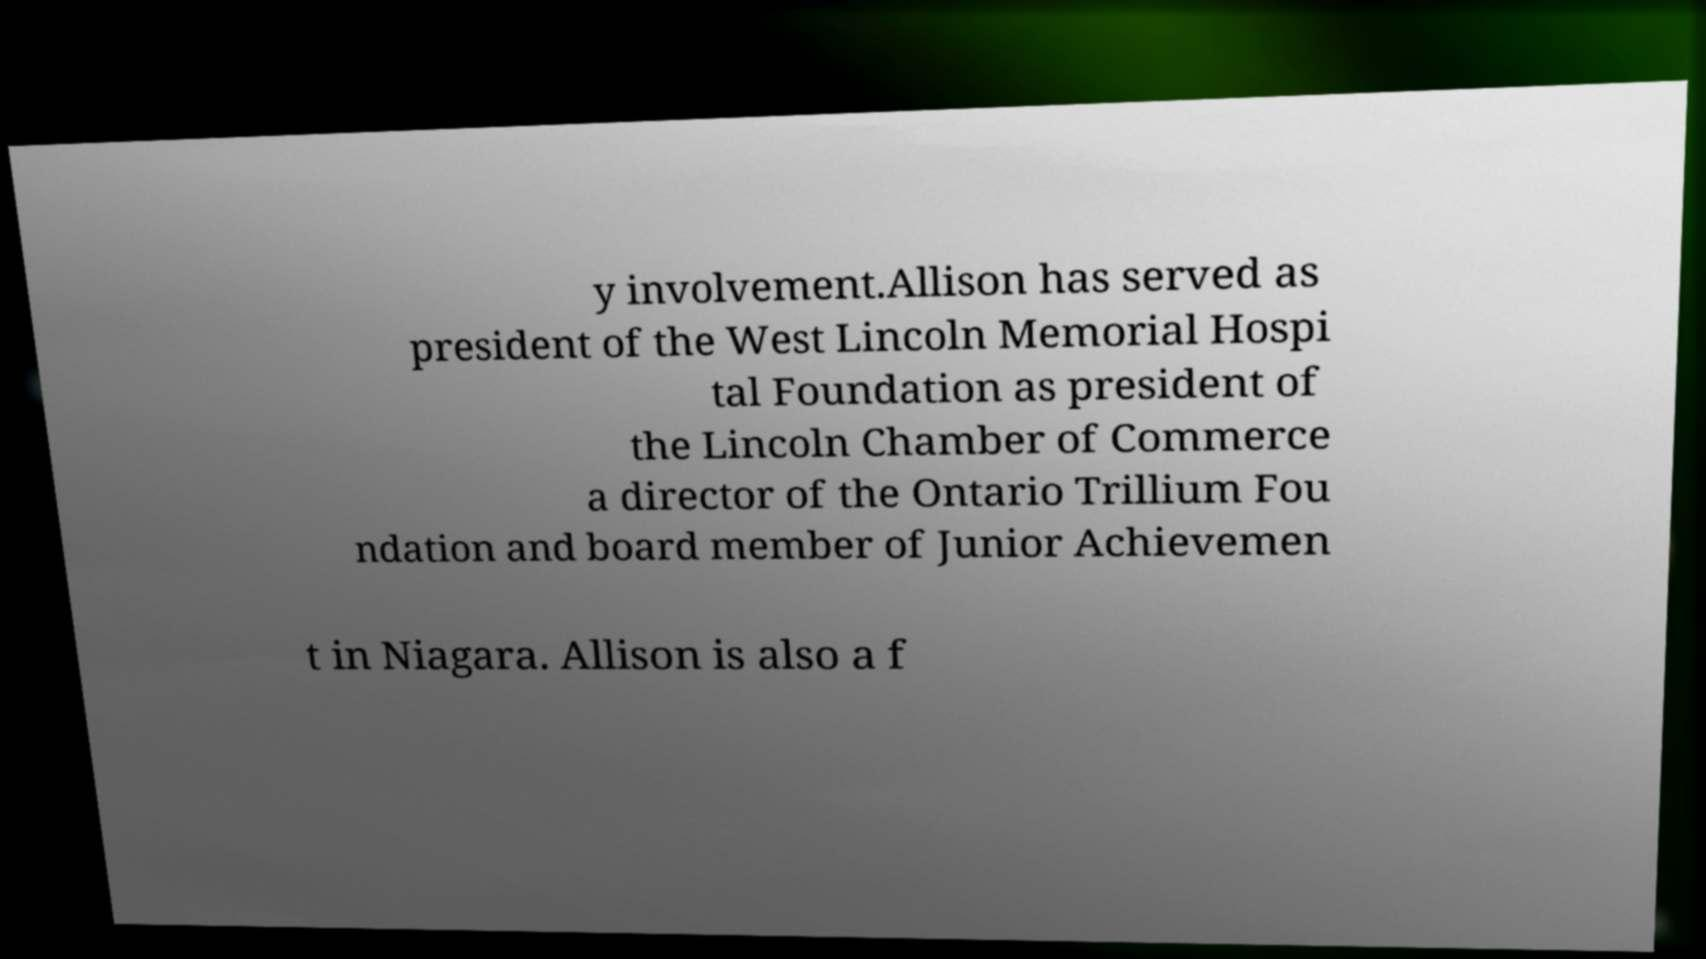What messages or text are displayed in this image? I need them in a readable, typed format. y involvement.Allison has served as president of the West Lincoln Memorial Hospi tal Foundation as president of the Lincoln Chamber of Commerce a director of the Ontario Trillium Fou ndation and board member of Junior Achievemen t in Niagara. Allison is also a f 